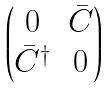<formula> <loc_0><loc_0><loc_500><loc_500>\begin{pmatrix} 0 & \bar { C } \\ \bar { C } ^ { \dagger } & 0 \end{pmatrix}</formula> 